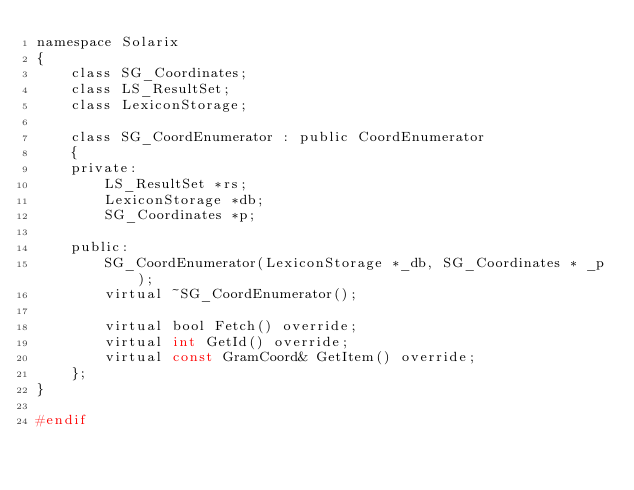Convert code to text. <code><loc_0><loc_0><loc_500><loc_500><_C_>namespace Solarix
{
    class SG_Coordinates;
    class LS_ResultSet;
    class LexiconStorage;

    class SG_CoordEnumerator : public CoordEnumerator
    {
    private:
        LS_ResultSet *rs;
        LexiconStorage *db;
        SG_Coordinates *p;

    public:
        SG_CoordEnumerator(LexiconStorage *_db, SG_Coordinates * _p);
        virtual ~SG_CoordEnumerator();

        virtual bool Fetch() override;
        virtual int GetId() override;
        virtual const GramCoord& GetItem() override;
    };
}

#endif
</code> 